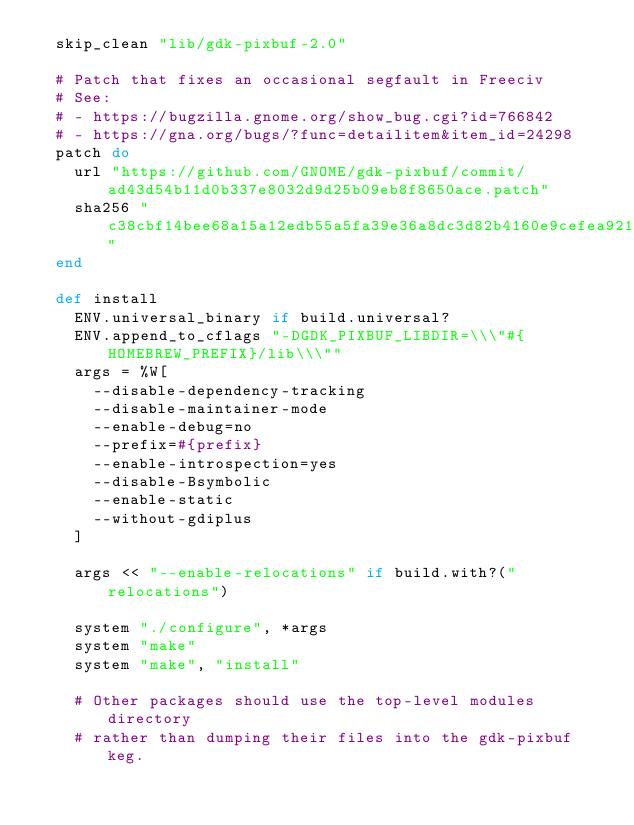Convert code to text. <code><loc_0><loc_0><loc_500><loc_500><_Ruby_>  skip_clean "lib/gdk-pixbuf-2.0"

  # Patch that fixes an occasional segfault in Freeciv
  # See:
  # - https://bugzilla.gnome.org/show_bug.cgi?id=766842
  # - https://gna.org/bugs/?func=detailitem&item_id=24298
  patch do
    url "https://github.com/GNOME/gdk-pixbuf/commit/ad43d54b11d0b337e8032d9d25b09eb8f8650ace.patch"
    sha256 "c38cbf14bee68a15a12edb55a5fa39e36a8dc3d82b4160e9cefea921eda6a13d"
  end

  def install
    ENV.universal_binary if build.universal?
    ENV.append_to_cflags "-DGDK_PIXBUF_LIBDIR=\\\"#{HOMEBREW_PREFIX}/lib\\\""
    args = %W[
      --disable-dependency-tracking
      --disable-maintainer-mode
      --enable-debug=no
      --prefix=#{prefix}
      --enable-introspection=yes
      --disable-Bsymbolic
      --enable-static
      --without-gdiplus
    ]

    args << "--enable-relocations" if build.with?("relocations")

    system "./configure", *args
    system "make"
    system "make", "install"

    # Other packages should use the top-level modules directory
    # rather than dumping their files into the gdk-pixbuf keg.</code> 